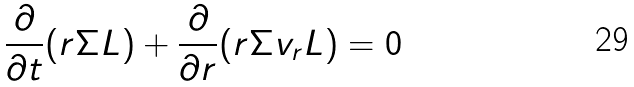<formula> <loc_0><loc_0><loc_500><loc_500>\frac { \partial } { \partial t } ( r \Sigma L ) + \frac { \partial } { \partial r } ( r \Sigma v _ { r } L ) = 0</formula> 